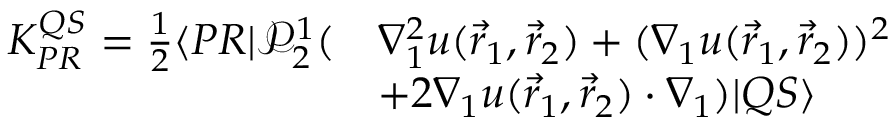<formula> <loc_0><loc_0><loc_500><loc_500>\begin{array} { r l } { K _ { P R } ^ { Q S } = \frac { 1 } { 2 } \langle { P R } | \mathcal { P } _ { 2 } ^ { 1 } ( } & { \nabla _ { 1 } ^ { 2 } u ( \vec { r } _ { 1 } , \vec { r } _ { 2 } ) + ( \nabla _ { 1 } u ( \vec { r } _ { 1 } , \vec { r } _ { 2 } ) ) ^ { 2 } } \\ & { + 2 \nabla _ { 1 } u ( \vec { r } _ { 1 } , \vec { r } _ { 2 } ) \cdot \nabla _ { 1 } ) | { Q S } \rangle } \end{array}</formula> 